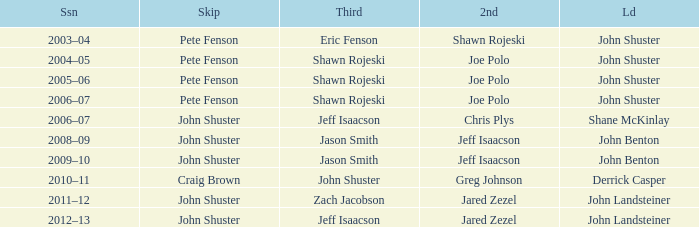Who was second when Shane McKinlay was the lead? Chris Plys. 